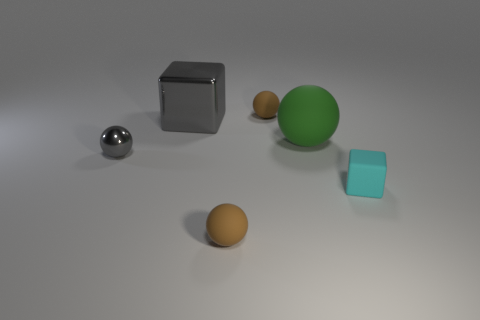Is the color of the small shiny thing the same as the big sphere?
Offer a terse response. No. How many objects are brown objects or small objects behind the big gray metallic block?
Give a very brief answer. 2. What size is the brown rubber object that is on the left side of the brown matte sphere behind the large thing that is to the left of the green rubber thing?
Keep it short and to the point. Small. What material is the cyan thing that is the same size as the gray ball?
Your response must be concise. Rubber. Are there any shiny cylinders that have the same size as the green ball?
Your answer should be very brief. No. There is a ball that is in front of the cyan matte thing; is it the same size as the gray cube?
Your answer should be very brief. No. The matte thing that is both left of the large matte sphere and in front of the large green matte sphere has what shape?
Make the answer very short. Sphere. Is the number of gray balls that are in front of the small gray shiny object greater than the number of big green spheres?
Your answer should be very brief. No. The object that is the same material as the large cube is what size?
Give a very brief answer. Small. What number of matte blocks are the same color as the small shiny ball?
Your answer should be compact. 0. 